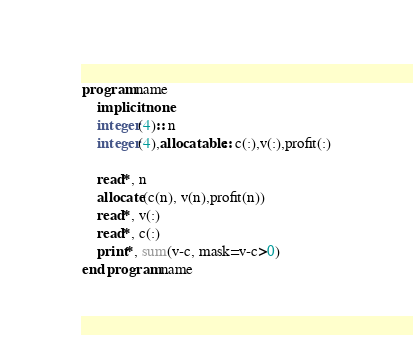<code> <loc_0><loc_0><loc_500><loc_500><_FORTRAN_>program name
    implicit none
    integer(4):: n
    integer(4),allocatable:: c(:),v(:),profit(:)

    read*, n
    allocate(c(n), v(n),profit(n))
    read*, v(:)
    read*, c(:)
    print*, sum(v-c, mask=v-c>0)
end program name</code> 